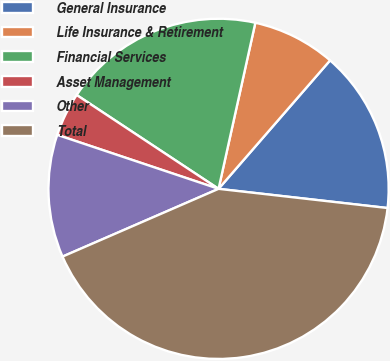Convert chart. <chart><loc_0><loc_0><loc_500><loc_500><pie_chart><fcel>General Insurance<fcel>Life Insurance & Retirement<fcel>Financial Services<fcel>Asset Management<fcel>Other<fcel>Total<nl><fcel>15.42%<fcel>7.91%<fcel>19.17%<fcel>4.16%<fcel>11.66%<fcel>41.68%<nl></chart> 